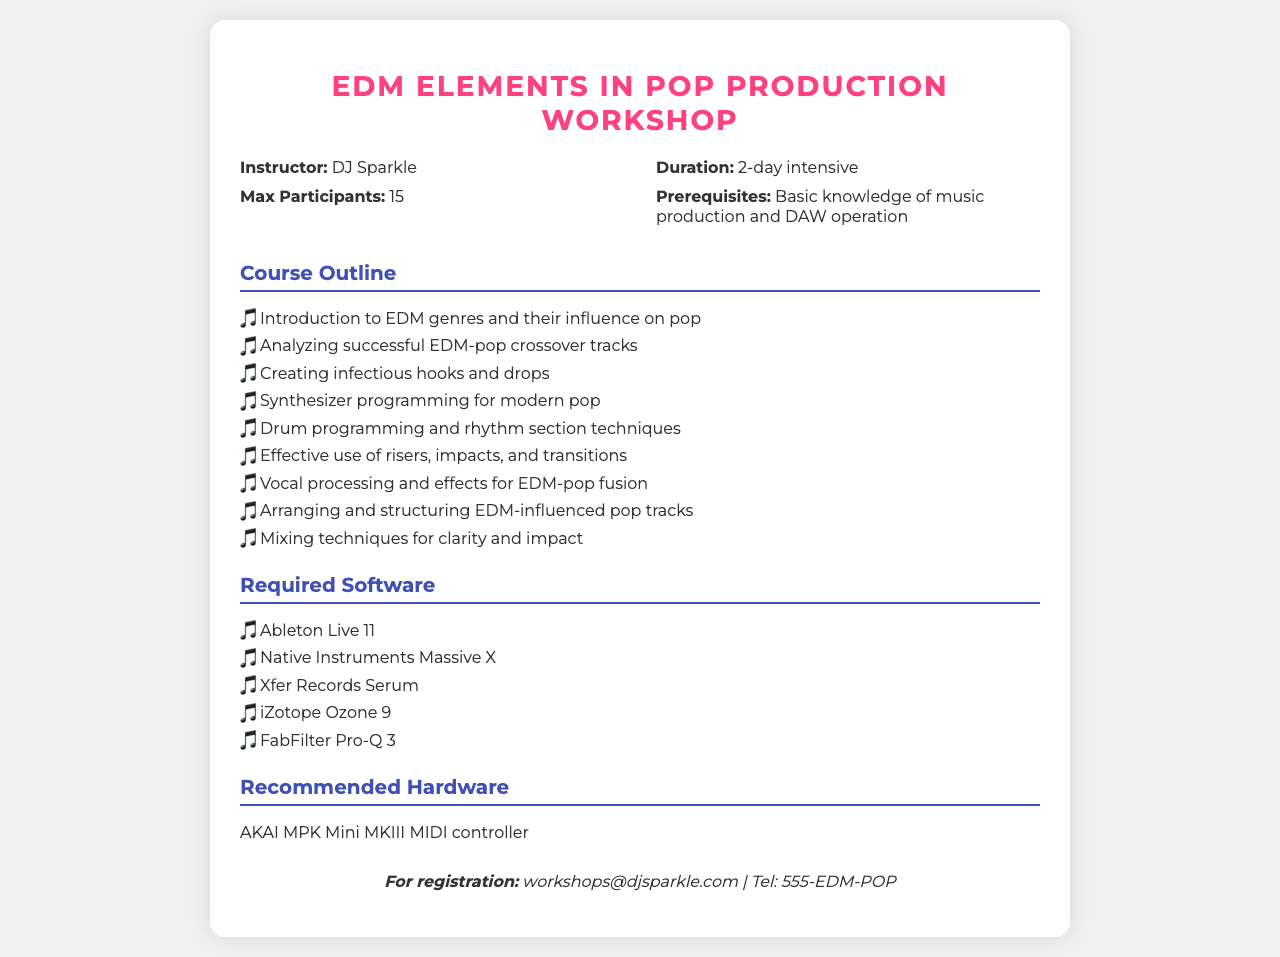What is the name of the instructor? The instructor for the workshop is specifically named in the document.
Answer: DJ Sparkle How long is the workshop? The duration of the workshop is stated clearly in the document.
Answer: 2-day intensive What is the maximum number of participants allowed? The document specifies the limit on participants for the workshop.
Answer: 15 What is a prerequisite for attending the workshop? The document lists a requirement for participants to have some prior knowledge.
Answer: Basic knowledge of music production and DAW operation Which software is required for the workshop? The document lists the software needed to participate in the workshop activities.
Answer: Ableton Live 11 What genre influences are explored in the course outline? The document indicates the type of music genre that will be analyzed in the workshop.
Answer: EDM genres What is the recommended MIDI controller for the workshop? The document mentions a specific hardware recommendation.
Answer: AKAI MPK Mini MKIII What is the contact email for registration? The document provides a specific email address for workshop registration inquiries.
Answer: workshops@djsparkle.com What is the focus of the course outline? The overall theme of the document focuses on integrating certain musical elements.
Answer: EDM-elements in pop productions 